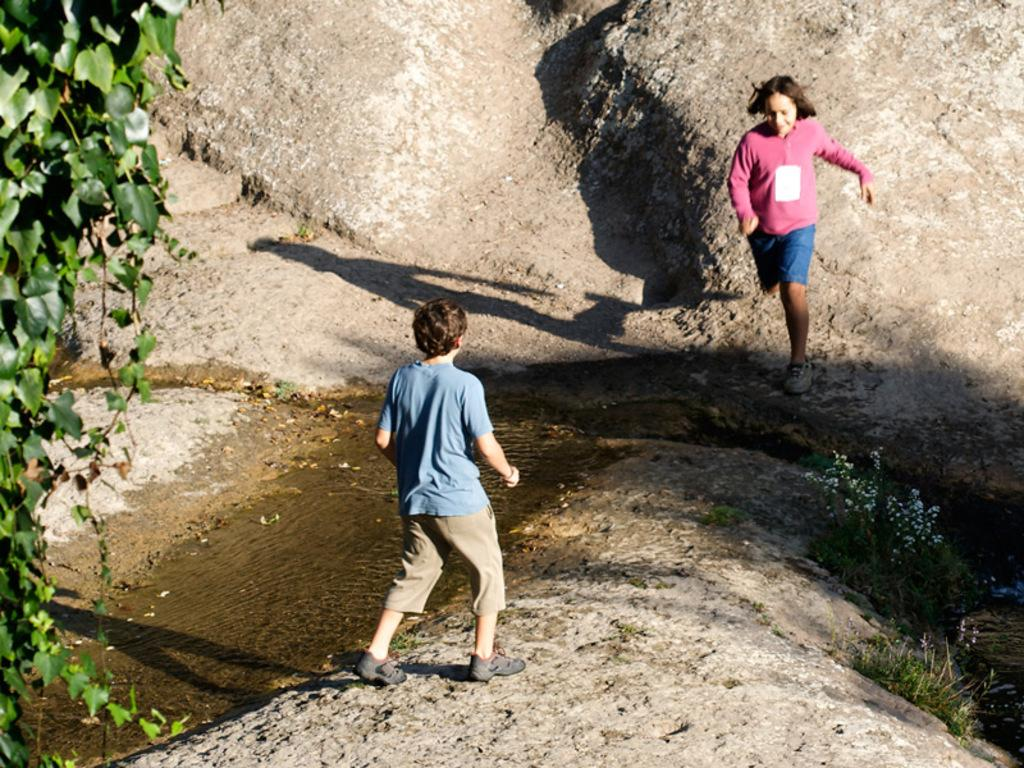Who or what can be seen in the image? There are people in the image. What else is present in the image besides people? There are plants, water, and mountains visible in the image. What type of kitty can be seen playing with a net in the image? There is no kitty or net present in the image; it features people, plants, water, and mountains. 